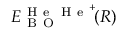<formula> <loc_0><loc_0><loc_500><loc_500>E _ { B O } ^ { H e H e ^ { + } } \, ( R )</formula> 